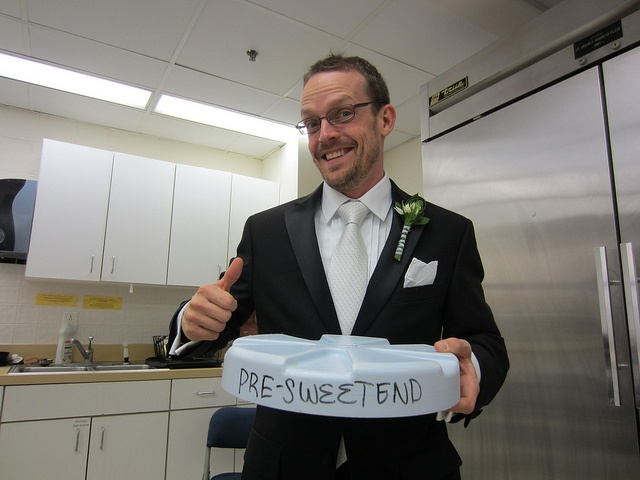Describe the objects in this image and their specific colors. I can see people in gray, black, darkgray, and brown tones, refrigerator in gray, darkgray, and black tones, tie in gray, darkgray, and lightgray tones, chair in gray and black tones, and sink in gray, darkgray, and black tones in this image. 